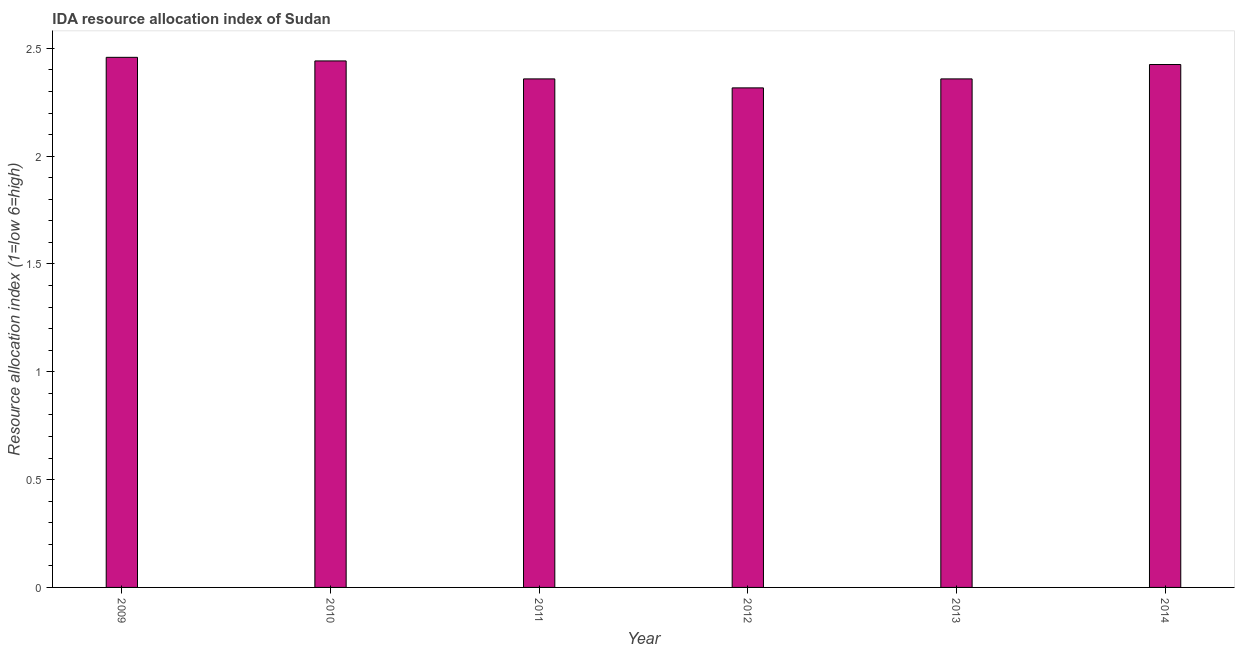What is the title of the graph?
Make the answer very short. IDA resource allocation index of Sudan. What is the label or title of the Y-axis?
Ensure brevity in your answer.  Resource allocation index (1=low 6=high). What is the ida resource allocation index in 2013?
Your response must be concise. 2.36. Across all years, what is the maximum ida resource allocation index?
Provide a short and direct response. 2.46. Across all years, what is the minimum ida resource allocation index?
Provide a succinct answer. 2.32. What is the sum of the ida resource allocation index?
Your answer should be very brief. 14.36. What is the difference between the ida resource allocation index in 2009 and 2012?
Ensure brevity in your answer.  0.14. What is the average ida resource allocation index per year?
Your answer should be compact. 2.39. What is the median ida resource allocation index?
Your answer should be very brief. 2.39. In how many years, is the ida resource allocation index greater than 1.2 ?
Your response must be concise. 6. What is the ratio of the ida resource allocation index in 2010 to that in 2014?
Give a very brief answer. 1.01. What is the difference between the highest and the second highest ida resource allocation index?
Give a very brief answer. 0.02. What is the difference between the highest and the lowest ida resource allocation index?
Your answer should be very brief. 0.14. In how many years, is the ida resource allocation index greater than the average ida resource allocation index taken over all years?
Keep it short and to the point. 3. How many bars are there?
Offer a very short reply. 6. Are all the bars in the graph horizontal?
Offer a very short reply. No. Are the values on the major ticks of Y-axis written in scientific E-notation?
Offer a terse response. No. What is the Resource allocation index (1=low 6=high) of 2009?
Your response must be concise. 2.46. What is the Resource allocation index (1=low 6=high) of 2010?
Offer a very short reply. 2.44. What is the Resource allocation index (1=low 6=high) in 2011?
Keep it short and to the point. 2.36. What is the Resource allocation index (1=low 6=high) of 2012?
Offer a terse response. 2.32. What is the Resource allocation index (1=low 6=high) of 2013?
Provide a short and direct response. 2.36. What is the Resource allocation index (1=low 6=high) of 2014?
Give a very brief answer. 2.42. What is the difference between the Resource allocation index (1=low 6=high) in 2009 and 2010?
Your response must be concise. 0.02. What is the difference between the Resource allocation index (1=low 6=high) in 2009 and 2011?
Offer a terse response. 0.1. What is the difference between the Resource allocation index (1=low 6=high) in 2009 and 2012?
Your response must be concise. 0.14. What is the difference between the Resource allocation index (1=low 6=high) in 2009 and 2014?
Keep it short and to the point. 0.03. What is the difference between the Resource allocation index (1=low 6=high) in 2010 and 2011?
Offer a very short reply. 0.08. What is the difference between the Resource allocation index (1=low 6=high) in 2010 and 2012?
Offer a very short reply. 0.12. What is the difference between the Resource allocation index (1=low 6=high) in 2010 and 2013?
Ensure brevity in your answer.  0.08. What is the difference between the Resource allocation index (1=low 6=high) in 2010 and 2014?
Your answer should be very brief. 0.02. What is the difference between the Resource allocation index (1=low 6=high) in 2011 and 2012?
Ensure brevity in your answer.  0.04. What is the difference between the Resource allocation index (1=low 6=high) in 2011 and 2013?
Give a very brief answer. 0. What is the difference between the Resource allocation index (1=low 6=high) in 2011 and 2014?
Keep it short and to the point. -0.07. What is the difference between the Resource allocation index (1=low 6=high) in 2012 and 2013?
Ensure brevity in your answer.  -0.04. What is the difference between the Resource allocation index (1=low 6=high) in 2012 and 2014?
Provide a succinct answer. -0.11. What is the difference between the Resource allocation index (1=low 6=high) in 2013 and 2014?
Ensure brevity in your answer.  -0.07. What is the ratio of the Resource allocation index (1=low 6=high) in 2009 to that in 2010?
Your response must be concise. 1.01. What is the ratio of the Resource allocation index (1=low 6=high) in 2009 to that in 2011?
Give a very brief answer. 1.04. What is the ratio of the Resource allocation index (1=low 6=high) in 2009 to that in 2012?
Your answer should be very brief. 1.06. What is the ratio of the Resource allocation index (1=low 6=high) in 2009 to that in 2013?
Offer a very short reply. 1.04. What is the ratio of the Resource allocation index (1=low 6=high) in 2010 to that in 2011?
Provide a short and direct response. 1.03. What is the ratio of the Resource allocation index (1=low 6=high) in 2010 to that in 2012?
Provide a short and direct response. 1.05. What is the ratio of the Resource allocation index (1=low 6=high) in 2010 to that in 2013?
Offer a terse response. 1.03. What is the ratio of the Resource allocation index (1=low 6=high) in 2011 to that in 2013?
Offer a very short reply. 1. What is the ratio of the Resource allocation index (1=low 6=high) in 2011 to that in 2014?
Give a very brief answer. 0.97. What is the ratio of the Resource allocation index (1=low 6=high) in 2012 to that in 2014?
Keep it short and to the point. 0.95. 